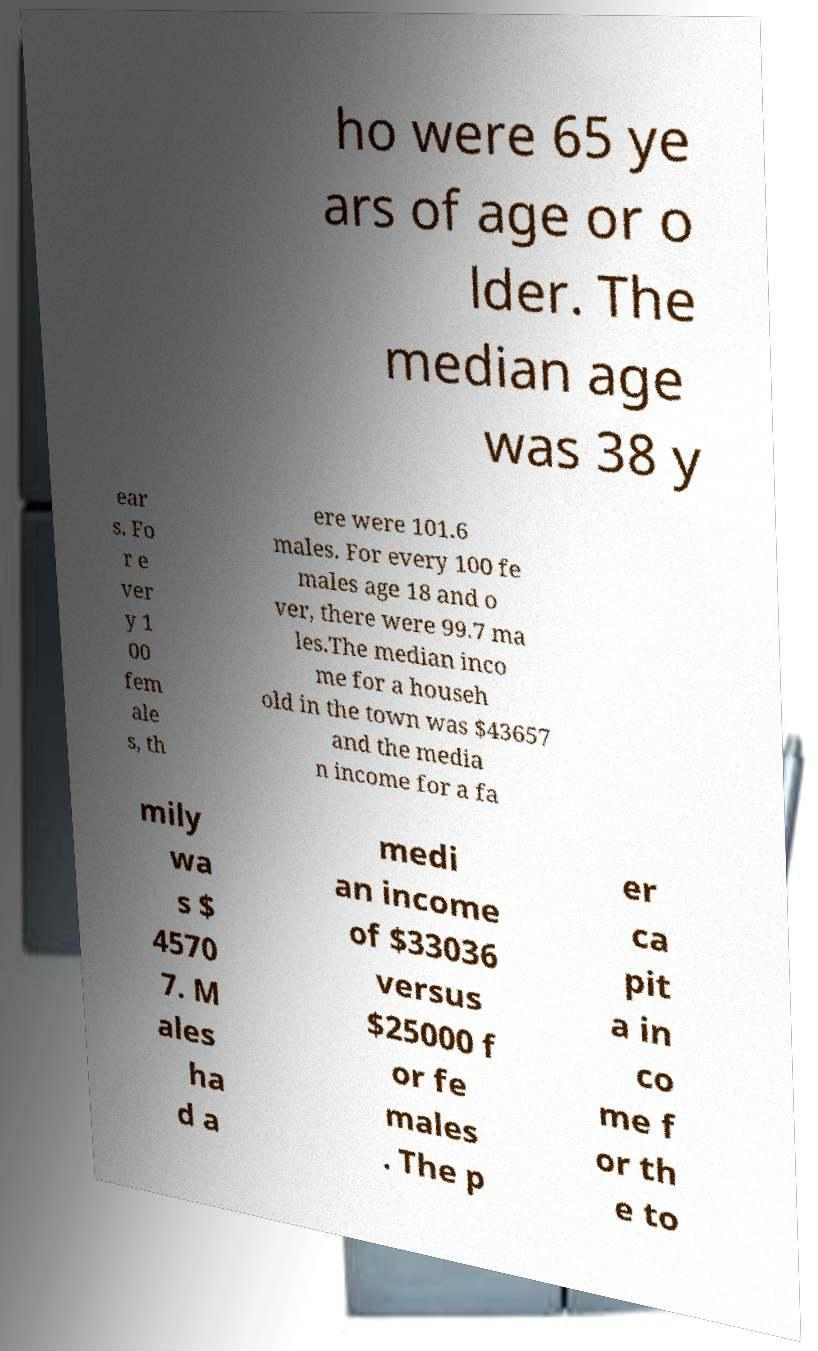Could you assist in decoding the text presented in this image and type it out clearly? ho were 65 ye ars of age or o lder. The median age was 38 y ear s. Fo r e ver y 1 00 fem ale s, th ere were 101.6 males. For every 100 fe males age 18 and o ver, there were 99.7 ma les.The median inco me for a househ old in the town was $43657 and the media n income for a fa mily wa s $ 4570 7. M ales ha d a medi an income of $33036 versus $25000 f or fe males . The p er ca pit a in co me f or th e to 